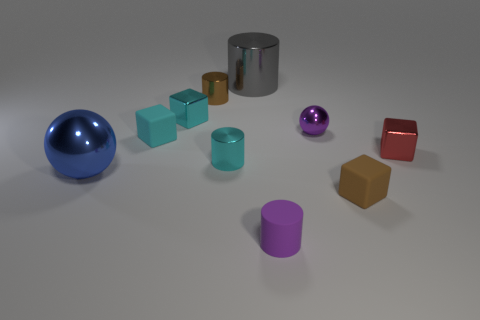Subtract all blue cubes. Subtract all green balls. How many cubes are left? 4 Subtract all cubes. How many objects are left? 6 Subtract all big brown metal things. Subtract all red things. How many objects are left? 9 Add 9 red objects. How many red objects are left? 10 Add 8 big objects. How many big objects exist? 10 Subtract 0 purple blocks. How many objects are left? 10 